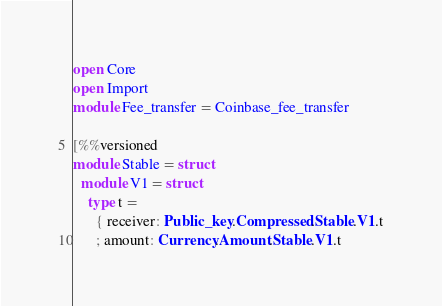Convert code to text. <code><loc_0><loc_0><loc_500><loc_500><_OCaml_>open Core
open Import
module Fee_transfer = Coinbase_fee_transfer

[%%versioned
module Stable = struct
  module V1 = struct
    type t =
      { receiver: Public_key.Compressed.Stable.V1.t
      ; amount: Currency.Amount.Stable.V1.t</code> 